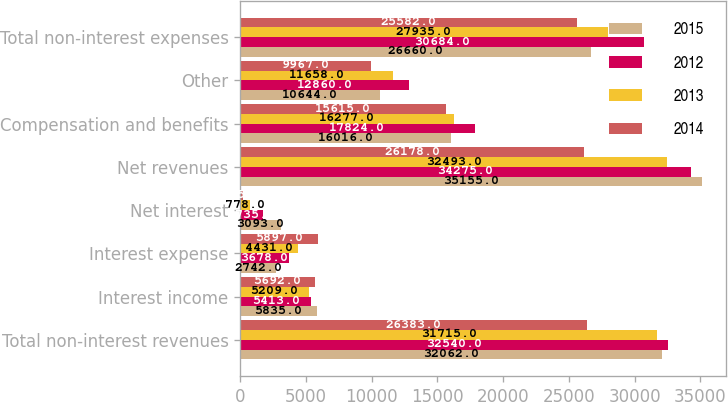Convert chart to OTSL. <chart><loc_0><loc_0><loc_500><loc_500><stacked_bar_chart><ecel><fcel>Total non-interest revenues<fcel>Interest income<fcel>Interest expense<fcel>Net interest<fcel>Net revenues<fcel>Compensation and benefits<fcel>Other<fcel>Total non-interest expenses<nl><fcel>2015<fcel>32062<fcel>5835<fcel>2742<fcel>3093<fcel>35155<fcel>16016<fcel>10644<fcel>26660<nl><fcel>2012<fcel>32540<fcel>5413<fcel>3678<fcel>1735<fcel>34275<fcel>17824<fcel>12860<fcel>30684<nl><fcel>2013<fcel>31715<fcel>5209<fcel>4431<fcel>778<fcel>32493<fcel>16277<fcel>11658<fcel>27935<nl><fcel>2014<fcel>26383<fcel>5692<fcel>5897<fcel>205<fcel>26178<fcel>15615<fcel>9967<fcel>25582<nl></chart> 